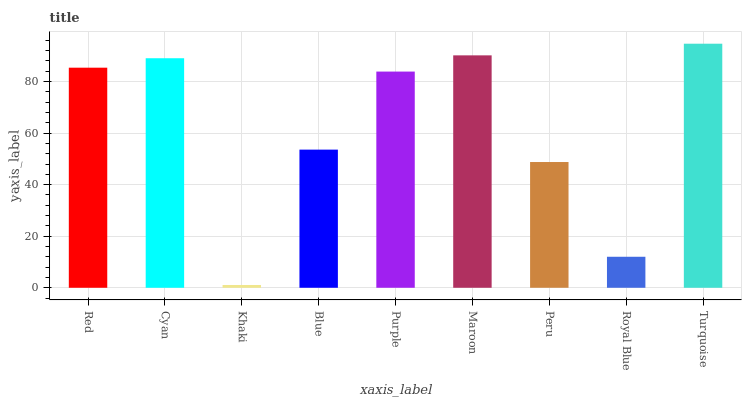Is Cyan the minimum?
Answer yes or no. No. Is Cyan the maximum?
Answer yes or no. No. Is Cyan greater than Red?
Answer yes or no. Yes. Is Red less than Cyan?
Answer yes or no. Yes. Is Red greater than Cyan?
Answer yes or no. No. Is Cyan less than Red?
Answer yes or no. No. Is Purple the high median?
Answer yes or no. Yes. Is Purple the low median?
Answer yes or no. Yes. Is Royal Blue the high median?
Answer yes or no. No. Is Blue the low median?
Answer yes or no. No. 